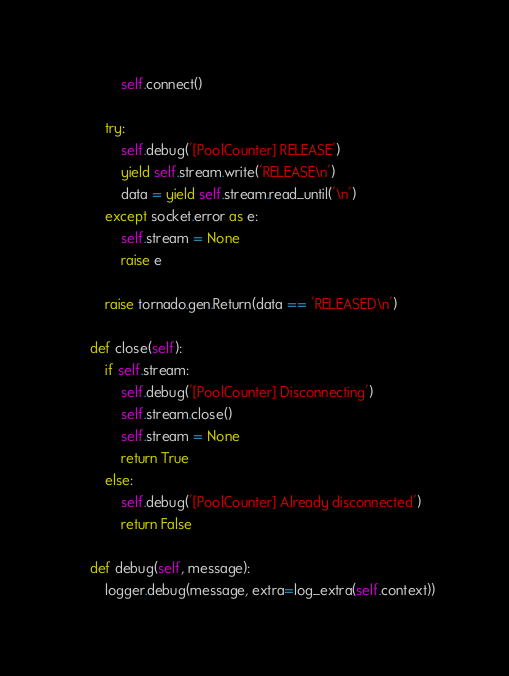<code> <loc_0><loc_0><loc_500><loc_500><_Python_>            self.connect()

        try:
            self.debug('[PoolCounter] RELEASE')
            yield self.stream.write('RELEASE\n')
            data = yield self.stream.read_until('\n')
        except socket.error as e:
            self.stream = None
            raise e

        raise tornado.gen.Return(data == 'RELEASED\n')

    def close(self):
        if self.stream:
            self.debug('[PoolCounter] Disconnecting')
            self.stream.close()
            self.stream = None
            return True
        else:
            self.debug('[PoolCounter] Already disconnected')
            return False

    def debug(self, message):
        logger.debug(message, extra=log_extra(self.context))
</code> 